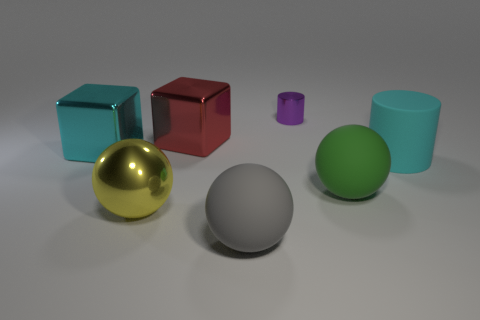There is a big metal cube to the left of the big red block; does it have the same color as the matte cylinder?
Your response must be concise. Yes. Is there a large object of the same color as the big matte cylinder?
Your answer should be very brief. Yes. Does the red thing have the same material as the cyan object left of the large gray object?
Your answer should be compact. Yes. Is there a red block on the right side of the big cyan thing that is on the left side of the cyan object on the right side of the yellow metallic ball?
Provide a short and direct response. Yes. Is there anything else that is the same size as the shiny cylinder?
Ensure brevity in your answer.  No. There is a sphere that is made of the same material as the big red cube; what color is it?
Provide a short and direct response. Yellow. What is the size of the object that is right of the big gray matte object and behind the large cyan matte cylinder?
Keep it short and to the point. Small. Are there fewer cyan rubber objects that are behind the big cyan rubber cylinder than large matte things that are in front of the small purple cylinder?
Make the answer very short. Yes. Is the material of the object left of the large yellow object the same as the cylinder that is in front of the red shiny cube?
Keep it short and to the point. No. What is the material of the big cube that is the same color as the rubber cylinder?
Your answer should be very brief. Metal. 